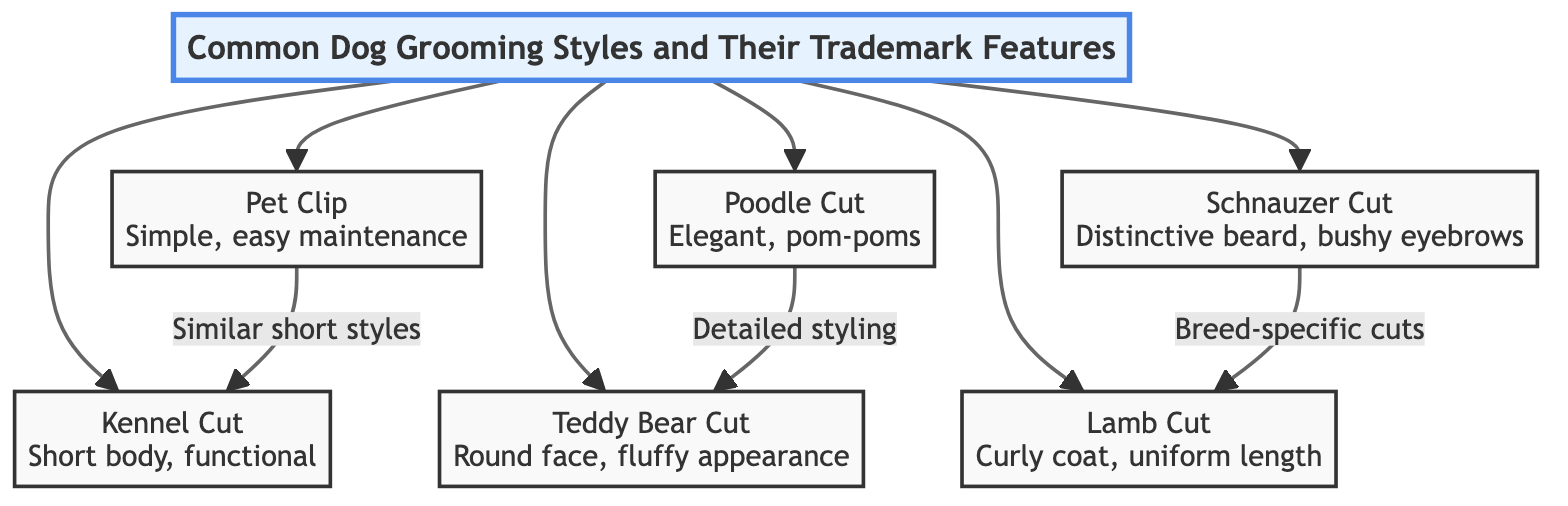What are the trademark features of the Pet Clip? The Pet Clip is described as "Simple, easy maintenance," which outlines its primary characteristics. The diagram directly associates this phrase with the Pet Clip style.
Answer: Simple, easy maintenance How many grooming styles are listed in the diagram? The diagram lists a total of 6 unique grooming styles for dogs: Pet Clip, Kennel Cut, Poodle Cut, Teddy Bear Cut, Schnauzer Cut, and Lamb Cut. This can be counted directly from the nodes connected to the title.
Answer: 6 Which grooming style has a distinctive beard? The Schnauzer Cut is noted for having a "Distinctive beard" as part of its trademark features, which is specifically stated in the diagram.
Answer: Schnauzer Cut What type of cut is characterized by a fluffy appearance? The Teddy Bear Cut is characterized by a "Round face, fluffy appearance," as indicated in the diagram. This description identifies its unique feature.
Answer: Teddy Bear Cut Which grooming styles are similar in terms of maintenance? The Pet Clip and Kennel Cut are linked by the phrase "Similar short styles," indicating they share comparable maintenance characteristics according to the diagram's connections.
Answer: Pet Clip, Kennel Cut What grooming style is associated with curly coats? The Lamb Cut is associated with "Curly coat, uniform length," as mentioned in the features for that style in the diagram. This description clearly describes the characteristics of the Lamb Cut.
Answer: Lamb Cut Which grooming style leads to detailed styling? The Poodle Cut is indicated to lead to "Detailed styling" as part of its description in the diagram, showing that it is more intricate compared to the other styles.
Answer: Poodle Cut How are breed-specific cuts represented in the diagram? The relationship labeled "Breed-specific cuts" connects the Schnauzer Cut to the Lamb Cut, suggesting that these styles are tailored for specific dog breeds, as illustrated in the diagram’s links.
Answer: Breed-specific cuts Which grooming style features pom-poms? The Poodle Cut is described as "Elegant, pom-poms," directly referencing its distinctive feature that makes it recognizable.
Answer: Poodle Cut 